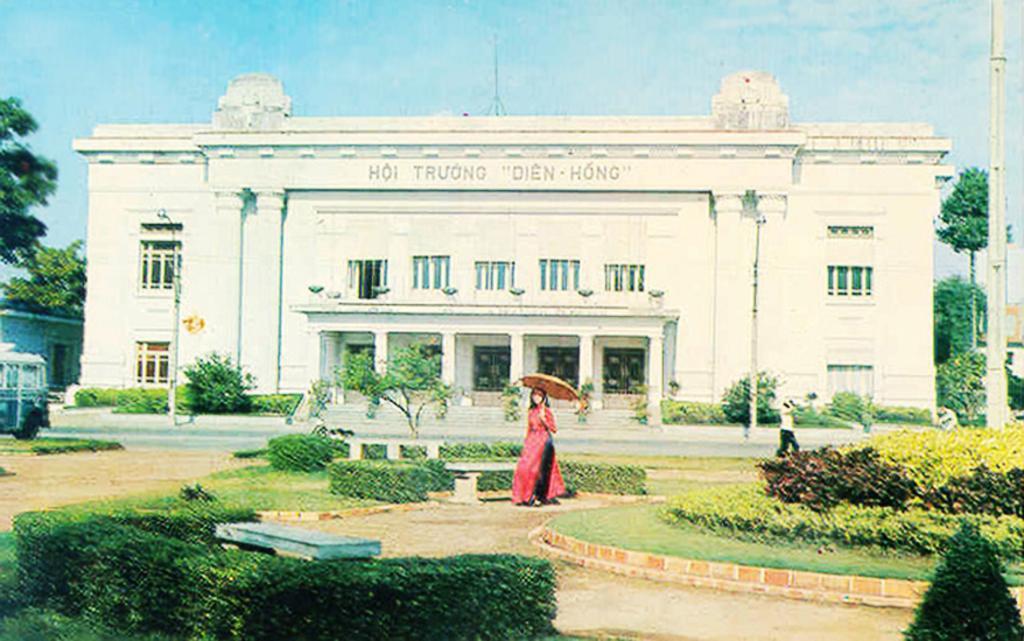How would you summarize this image in a sentence or two? In this image there is one women standing and holding an umbrella in the middle of this image. There is one person standing on the right side of this image. There are some plants in the bottom of this image. There is a building in the background. There are some trees on the left side of this image and right side of this image as well. There is a sky on the top of this image. 